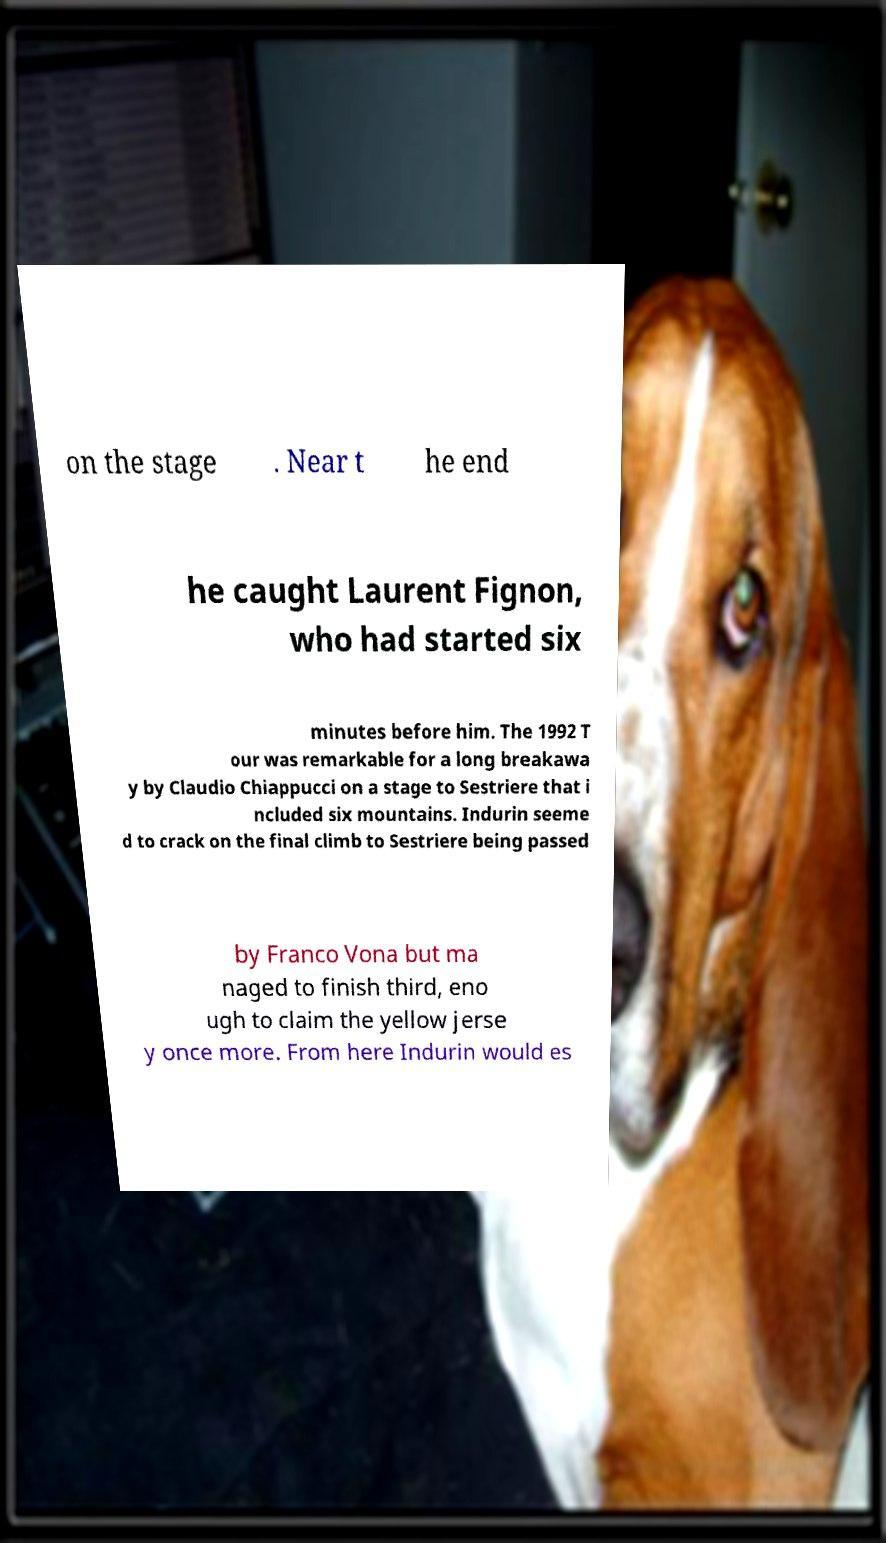Can you accurately transcribe the text from the provided image for me? on the stage . Near t he end he caught Laurent Fignon, who had started six minutes before him. The 1992 T our was remarkable for a long breakawa y by Claudio Chiappucci on a stage to Sestriere that i ncluded six mountains. Indurin seeme d to crack on the final climb to Sestriere being passed by Franco Vona but ma naged to finish third, eno ugh to claim the yellow jerse y once more. From here Indurin would es 